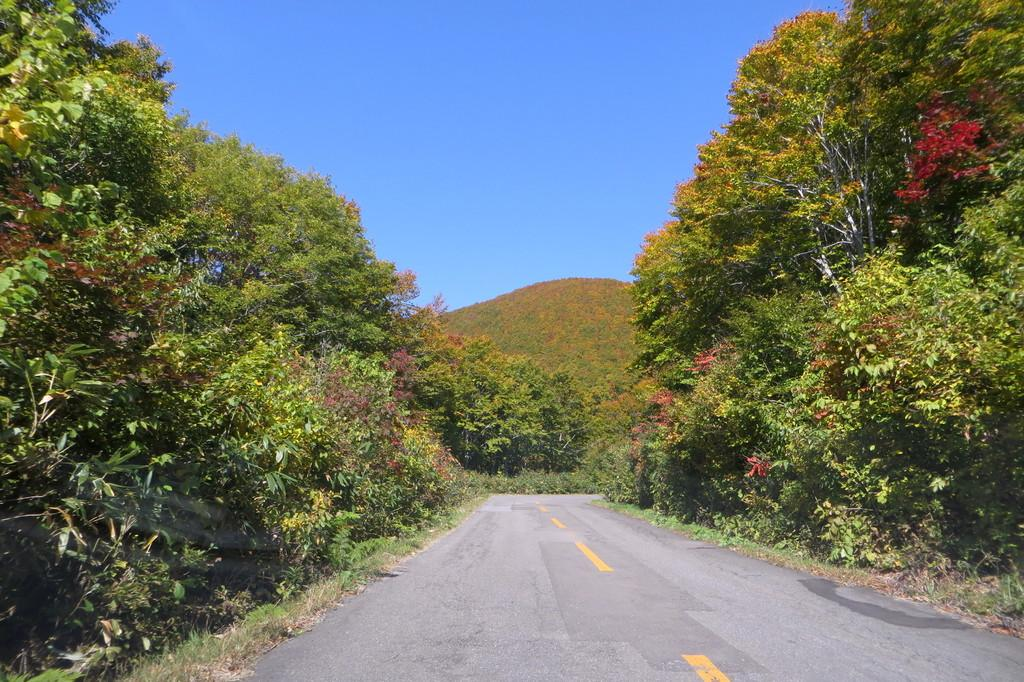What is the main feature of the image? There is a road in the image. What can be seen on the sides of the road? There are trees on the sides of the road. What is visible in the background of the image? There is a hill in the background of the image. What part of the natural environment is visible in the image? The sky is visible in the image. How many boats are visible in the image? There are no boats present in the image; it features a road, trees, a hill, and the sky. What type of wealth is depicted in the image? There is no depiction of wealth in the image; it focuses on the road, trees, hill, and sky. 